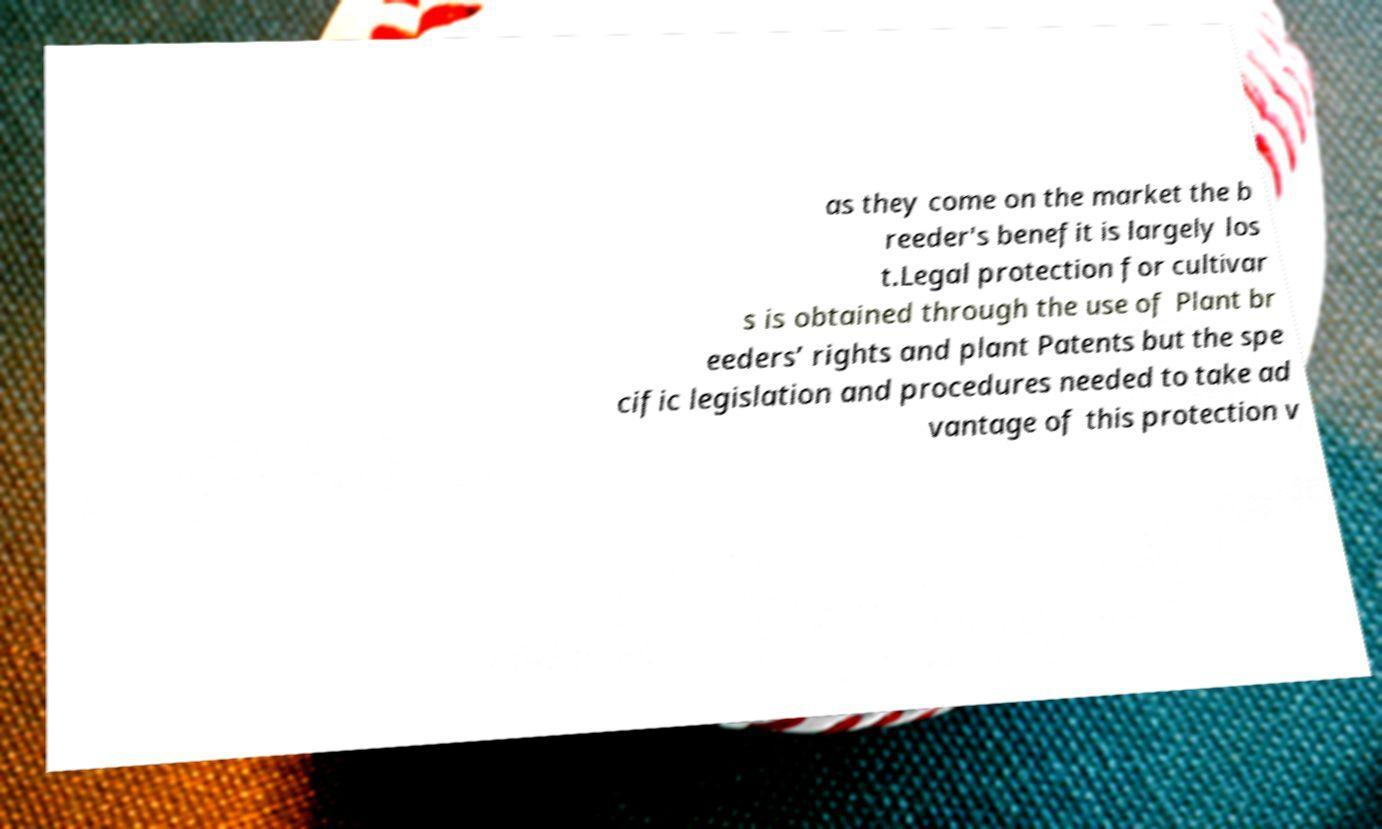For documentation purposes, I need the text within this image transcribed. Could you provide that? as they come on the market the b reeder's benefit is largely los t.Legal protection for cultivar s is obtained through the use of Plant br eeders’ rights and plant Patents but the spe cific legislation and procedures needed to take ad vantage of this protection v 